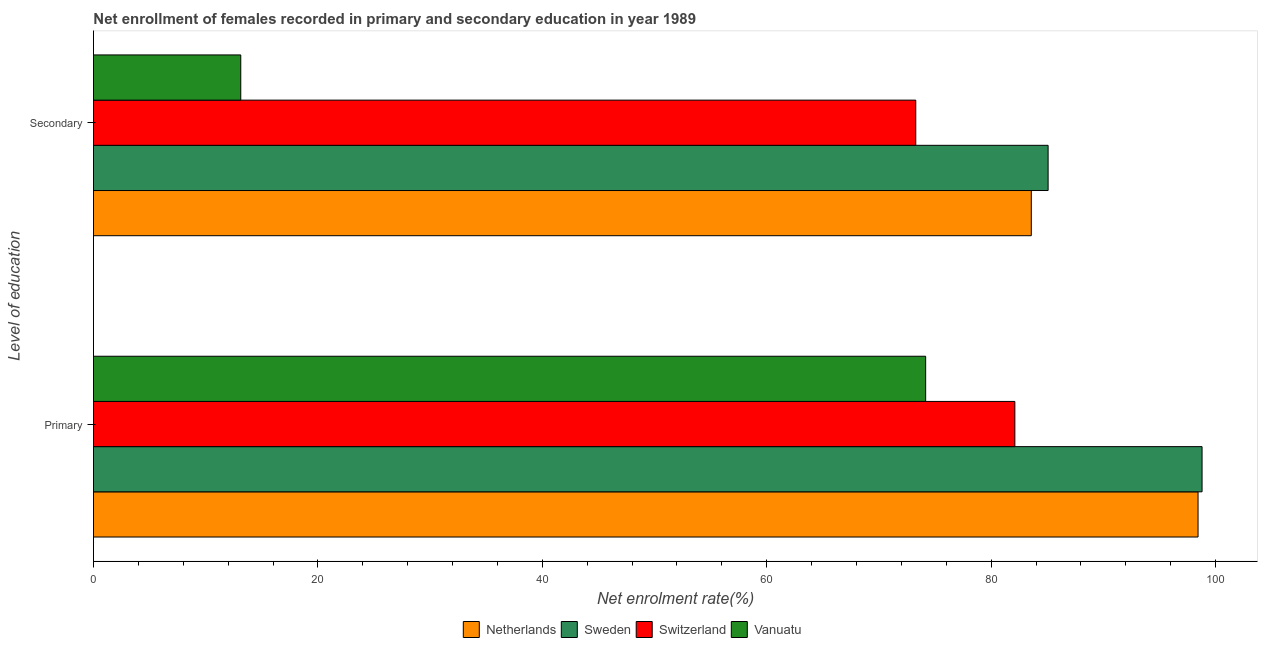What is the label of the 1st group of bars from the top?
Keep it short and to the point. Secondary. What is the enrollment rate in primary education in Switzerland?
Offer a very short reply. 82.11. Across all countries, what is the maximum enrollment rate in primary education?
Ensure brevity in your answer.  98.79. Across all countries, what is the minimum enrollment rate in secondary education?
Your response must be concise. 13.13. In which country was the enrollment rate in primary education maximum?
Your response must be concise. Sweden. In which country was the enrollment rate in primary education minimum?
Provide a short and direct response. Vanuatu. What is the total enrollment rate in primary education in the graph?
Keep it short and to the point. 353.5. What is the difference between the enrollment rate in primary education in Sweden and that in Vanuatu?
Make the answer very short. 24.63. What is the difference between the enrollment rate in primary education in Sweden and the enrollment rate in secondary education in Switzerland?
Provide a short and direct response. 25.51. What is the average enrollment rate in secondary education per country?
Your answer should be very brief. 63.76. What is the difference between the enrollment rate in primary education and enrollment rate in secondary education in Sweden?
Your response must be concise. 13.72. In how many countries, is the enrollment rate in secondary education greater than 16 %?
Your answer should be very brief. 3. What is the ratio of the enrollment rate in secondary education in Vanuatu to that in Switzerland?
Your answer should be very brief. 0.18. Is the enrollment rate in secondary education in Switzerland less than that in Vanuatu?
Provide a short and direct response. No. In how many countries, is the enrollment rate in primary education greater than the average enrollment rate in primary education taken over all countries?
Your answer should be very brief. 2. What does the 1st bar from the top in Secondary represents?
Make the answer very short. Vanuatu. What does the 3rd bar from the bottom in Primary represents?
Your answer should be very brief. Switzerland. Are all the bars in the graph horizontal?
Your answer should be very brief. Yes. How many countries are there in the graph?
Your response must be concise. 4. What is the difference between two consecutive major ticks on the X-axis?
Your answer should be very brief. 20. Does the graph contain any zero values?
Ensure brevity in your answer.  No. Does the graph contain grids?
Ensure brevity in your answer.  No. Where does the legend appear in the graph?
Your answer should be very brief. Bottom center. How many legend labels are there?
Provide a short and direct response. 4. How are the legend labels stacked?
Your answer should be compact. Horizontal. What is the title of the graph?
Keep it short and to the point. Net enrollment of females recorded in primary and secondary education in year 1989. Does "Curacao" appear as one of the legend labels in the graph?
Your answer should be compact. No. What is the label or title of the X-axis?
Your answer should be very brief. Net enrolment rate(%). What is the label or title of the Y-axis?
Provide a short and direct response. Level of education. What is the Net enrolment rate(%) in Netherlands in Primary?
Your answer should be very brief. 98.43. What is the Net enrolment rate(%) of Sweden in Primary?
Give a very brief answer. 98.79. What is the Net enrolment rate(%) of Switzerland in Primary?
Keep it short and to the point. 82.11. What is the Net enrolment rate(%) of Vanuatu in Primary?
Provide a succinct answer. 74.16. What is the Net enrolment rate(%) in Netherlands in Secondary?
Your response must be concise. 83.58. What is the Net enrolment rate(%) of Sweden in Secondary?
Make the answer very short. 85.07. What is the Net enrolment rate(%) in Switzerland in Secondary?
Your answer should be compact. 73.28. What is the Net enrolment rate(%) of Vanuatu in Secondary?
Keep it short and to the point. 13.13. Across all Level of education, what is the maximum Net enrolment rate(%) in Netherlands?
Offer a terse response. 98.43. Across all Level of education, what is the maximum Net enrolment rate(%) in Sweden?
Keep it short and to the point. 98.79. Across all Level of education, what is the maximum Net enrolment rate(%) in Switzerland?
Keep it short and to the point. 82.11. Across all Level of education, what is the maximum Net enrolment rate(%) of Vanuatu?
Make the answer very short. 74.16. Across all Level of education, what is the minimum Net enrolment rate(%) of Netherlands?
Offer a terse response. 83.58. Across all Level of education, what is the minimum Net enrolment rate(%) in Sweden?
Keep it short and to the point. 85.07. Across all Level of education, what is the minimum Net enrolment rate(%) of Switzerland?
Provide a short and direct response. 73.28. Across all Level of education, what is the minimum Net enrolment rate(%) in Vanuatu?
Your response must be concise. 13.13. What is the total Net enrolment rate(%) in Netherlands in the graph?
Keep it short and to the point. 182.01. What is the total Net enrolment rate(%) of Sweden in the graph?
Your response must be concise. 183.87. What is the total Net enrolment rate(%) of Switzerland in the graph?
Ensure brevity in your answer.  155.39. What is the total Net enrolment rate(%) of Vanuatu in the graph?
Offer a terse response. 87.29. What is the difference between the Net enrolment rate(%) of Netherlands in Primary and that in Secondary?
Ensure brevity in your answer.  14.86. What is the difference between the Net enrolment rate(%) in Sweden in Primary and that in Secondary?
Provide a short and direct response. 13.72. What is the difference between the Net enrolment rate(%) in Switzerland in Primary and that in Secondary?
Make the answer very short. 8.83. What is the difference between the Net enrolment rate(%) in Vanuatu in Primary and that in Secondary?
Keep it short and to the point. 61.03. What is the difference between the Net enrolment rate(%) in Netherlands in Primary and the Net enrolment rate(%) in Sweden in Secondary?
Your answer should be very brief. 13.36. What is the difference between the Net enrolment rate(%) of Netherlands in Primary and the Net enrolment rate(%) of Switzerland in Secondary?
Your answer should be compact. 25.15. What is the difference between the Net enrolment rate(%) in Netherlands in Primary and the Net enrolment rate(%) in Vanuatu in Secondary?
Provide a succinct answer. 85.31. What is the difference between the Net enrolment rate(%) in Sweden in Primary and the Net enrolment rate(%) in Switzerland in Secondary?
Provide a succinct answer. 25.51. What is the difference between the Net enrolment rate(%) in Sweden in Primary and the Net enrolment rate(%) in Vanuatu in Secondary?
Offer a terse response. 85.67. What is the difference between the Net enrolment rate(%) in Switzerland in Primary and the Net enrolment rate(%) in Vanuatu in Secondary?
Provide a short and direct response. 68.98. What is the average Net enrolment rate(%) in Netherlands per Level of education?
Make the answer very short. 91. What is the average Net enrolment rate(%) in Sweden per Level of education?
Provide a short and direct response. 91.93. What is the average Net enrolment rate(%) of Switzerland per Level of education?
Ensure brevity in your answer.  77.69. What is the average Net enrolment rate(%) in Vanuatu per Level of education?
Your answer should be very brief. 43.64. What is the difference between the Net enrolment rate(%) of Netherlands and Net enrolment rate(%) of Sweden in Primary?
Your answer should be very brief. -0.36. What is the difference between the Net enrolment rate(%) of Netherlands and Net enrolment rate(%) of Switzerland in Primary?
Provide a short and direct response. 16.32. What is the difference between the Net enrolment rate(%) in Netherlands and Net enrolment rate(%) in Vanuatu in Primary?
Offer a very short reply. 24.27. What is the difference between the Net enrolment rate(%) in Sweden and Net enrolment rate(%) in Switzerland in Primary?
Your answer should be very brief. 16.68. What is the difference between the Net enrolment rate(%) in Sweden and Net enrolment rate(%) in Vanuatu in Primary?
Ensure brevity in your answer.  24.63. What is the difference between the Net enrolment rate(%) in Switzerland and Net enrolment rate(%) in Vanuatu in Primary?
Provide a short and direct response. 7.95. What is the difference between the Net enrolment rate(%) in Netherlands and Net enrolment rate(%) in Sweden in Secondary?
Ensure brevity in your answer.  -1.5. What is the difference between the Net enrolment rate(%) of Netherlands and Net enrolment rate(%) of Switzerland in Secondary?
Keep it short and to the point. 10.3. What is the difference between the Net enrolment rate(%) in Netherlands and Net enrolment rate(%) in Vanuatu in Secondary?
Your answer should be compact. 70.45. What is the difference between the Net enrolment rate(%) in Sweden and Net enrolment rate(%) in Switzerland in Secondary?
Your answer should be compact. 11.79. What is the difference between the Net enrolment rate(%) of Sweden and Net enrolment rate(%) of Vanuatu in Secondary?
Offer a terse response. 71.95. What is the difference between the Net enrolment rate(%) of Switzerland and Net enrolment rate(%) of Vanuatu in Secondary?
Keep it short and to the point. 60.15. What is the ratio of the Net enrolment rate(%) in Netherlands in Primary to that in Secondary?
Provide a succinct answer. 1.18. What is the ratio of the Net enrolment rate(%) of Sweden in Primary to that in Secondary?
Make the answer very short. 1.16. What is the ratio of the Net enrolment rate(%) of Switzerland in Primary to that in Secondary?
Offer a terse response. 1.12. What is the ratio of the Net enrolment rate(%) in Vanuatu in Primary to that in Secondary?
Your answer should be compact. 5.65. What is the difference between the highest and the second highest Net enrolment rate(%) of Netherlands?
Offer a terse response. 14.86. What is the difference between the highest and the second highest Net enrolment rate(%) in Sweden?
Offer a terse response. 13.72. What is the difference between the highest and the second highest Net enrolment rate(%) in Switzerland?
Provide a short and direct response. 8.83. What is the difference between the highest and the second highest Net enrolment rate(%) of Vanuatu?
Your answer should be compact. 61.03. What is the difference between the highest and the lowest Net enrolment rate(%) of Netherlands?
Your answer should be very brief. 14.86. What is the difference between the highest and the lowest Net enrolment rate(%) in Sweden?
Offer a very short reply. 13.72. What is the difference between the highest and the lowest Net enrolment rate(%) of Switzerland?
Offer a very short reply. 8.83. What is the difference between the highest and the lowest Net enrolment rate(%) of Vanuatu?
Keep it short and to the point. 61.03. 